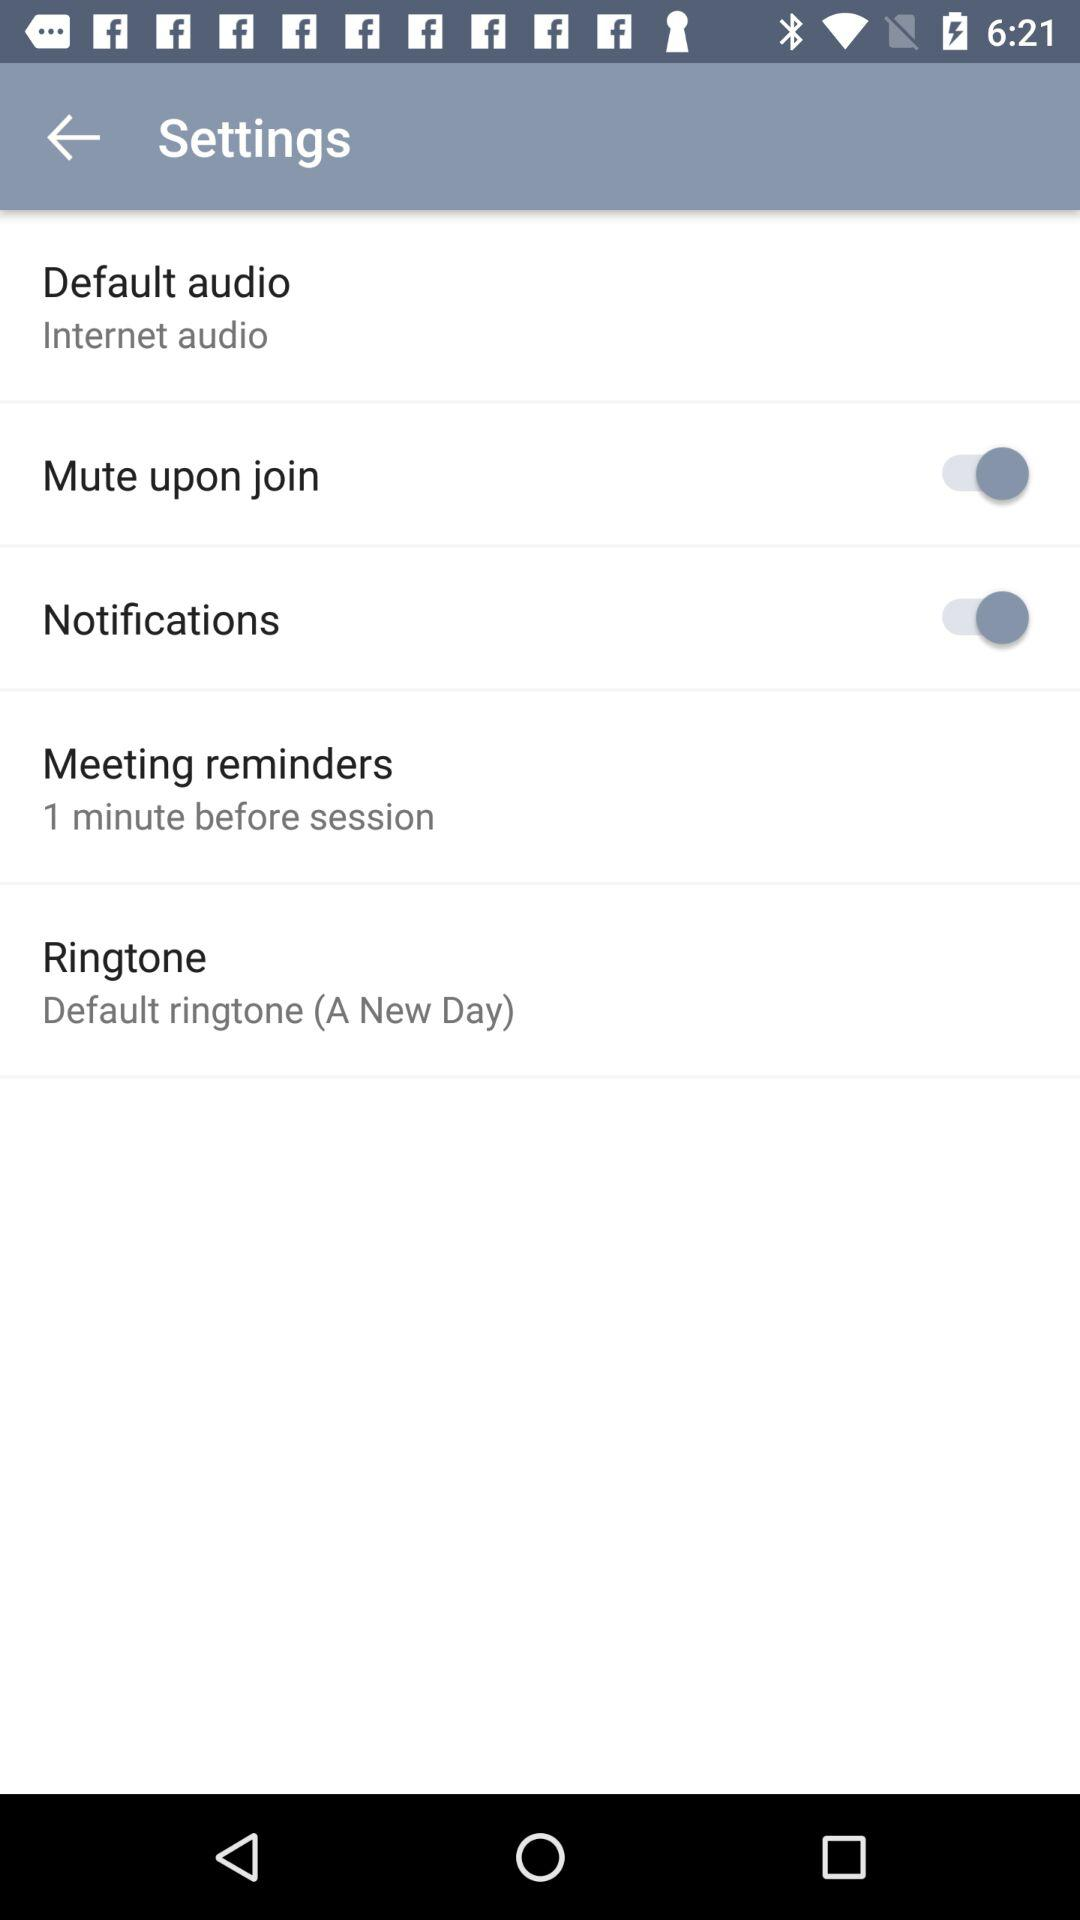How many items are there in the Settings menu?
Answer the question using a single word or phrase. 5 